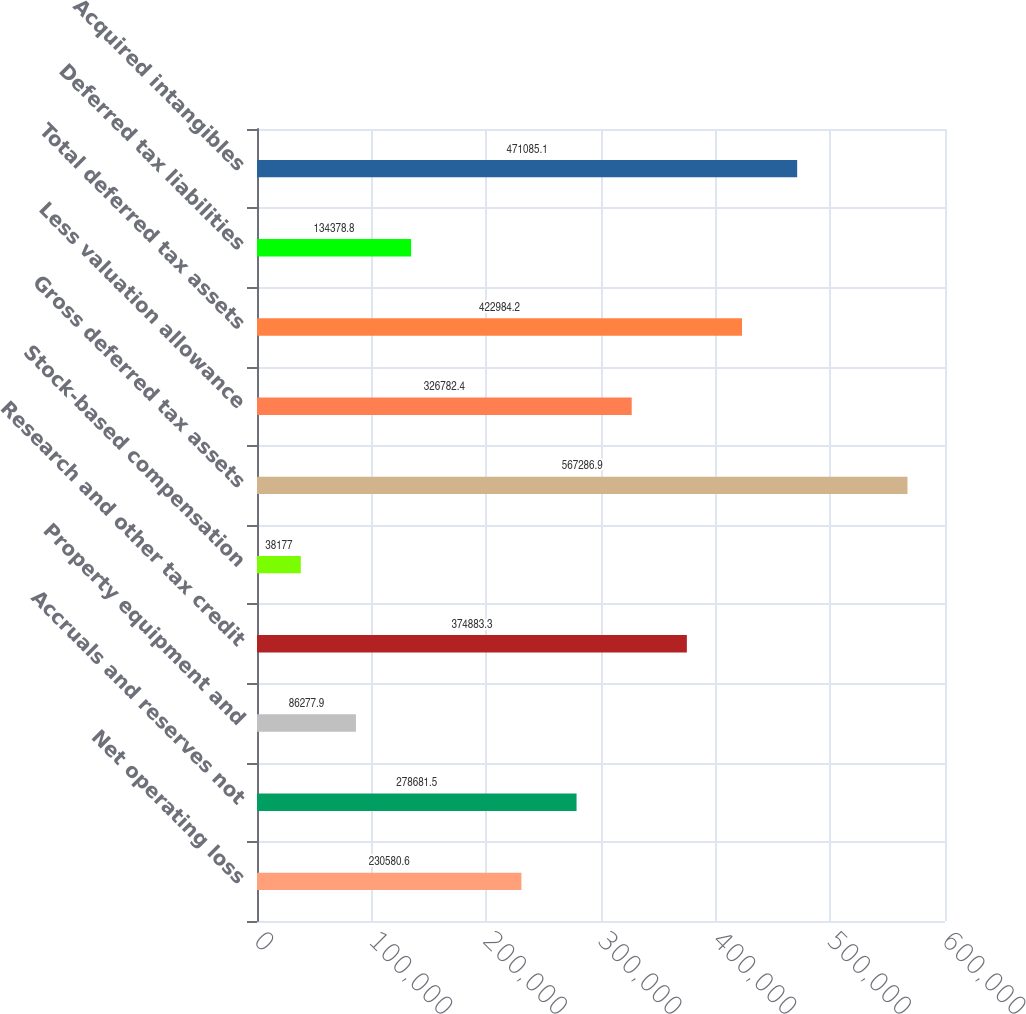Convert chart to OTSL. <chart><loc_0><loc_0><loc_500><loc_500><bar_chart><fcel>Net operating loss<fcel>Accruals and reserves not<fcel>Property equipment and<fcel>Research and other tax credit<fcel>Stock-based compensation<fcel>Gross deferred tax assets<fcel>Less valuation allowance<fcel>Total deferred tax assets<fcel>Deferred tax liabilities<fcel>Acquired intangibles<nl><fcel>230581<fcel>278682<fcel>86277.9<fcel>374883<fcel>38177<fcel>567287<fcel>326782<fcel>422984<fcel>134379<fcel>471085<nl></chart> 